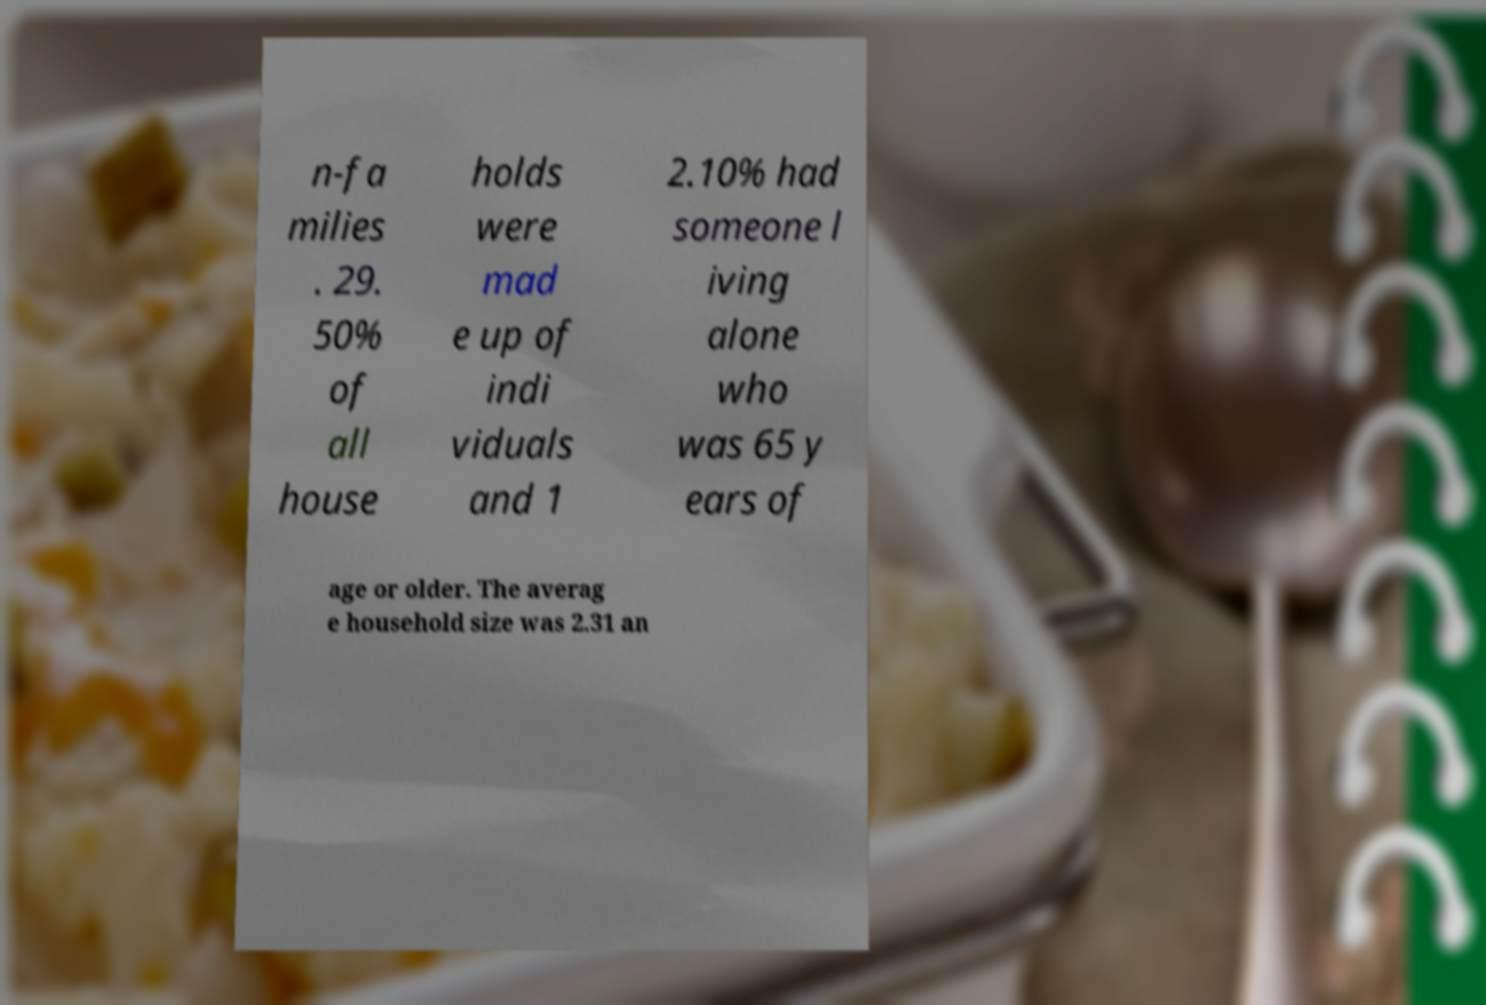What messages or text are displayed in this image? I need them in a readable, typed format. n-fa milies . 29. 50% of all house holds were mad e up of indi viduals and 1 2.10% had someone l iving alone who was 65 y ears of age or older. The averag e household size was 2.31 an 